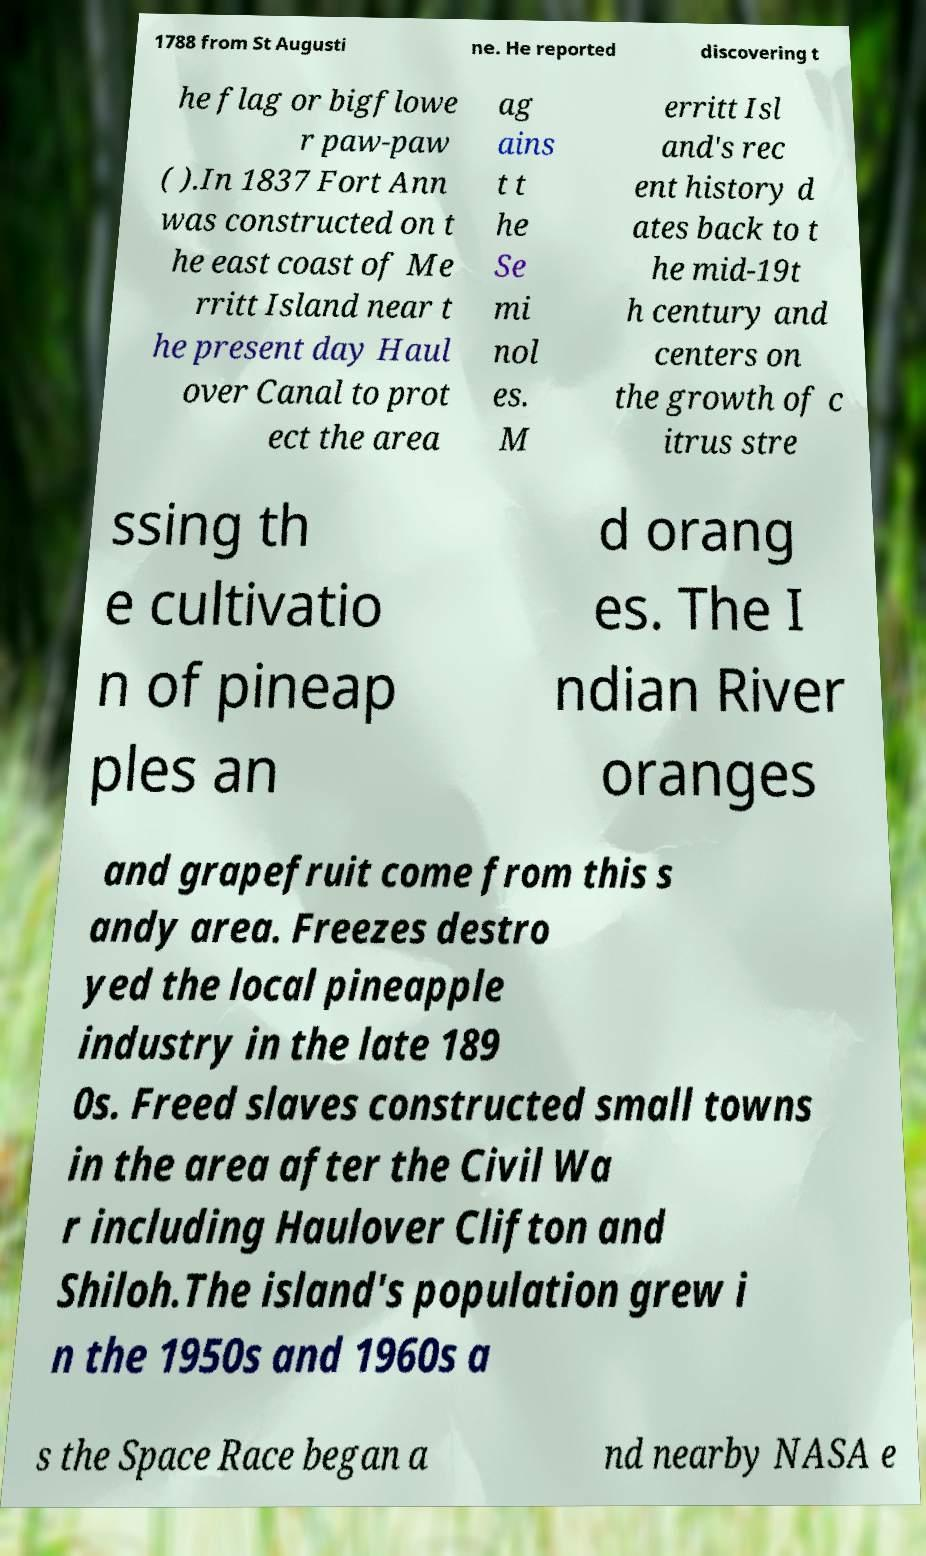What messages or text are displayed in this image? I need them in a readable, typed format. 1788 from St Augusti ne. He reported discovering t he flag or bigflowe r paw-paw ( ).In 1837 Fort Ann was constructed on t he east coast of Me rritt Island near t he present day Haul over Canal to prot ect the area ag ains t t he Se mi nol es. M erritt Isl and's rec ent history d ates back to t he mid-19t h century and centers on the growth of c itrus stre ssing th e cultivatio n of pineap ples an d orang es. The I ndian River oranges and grapefruit come from this s andy area. Freezes destro yed the local pineapple industry in the late 189 0s. Freed slaves constructed small towns in the area after the Civil Wa r including Haulover Clifton and Shiloh.The island's population grew i n the 1950s and 1960s a s the Space Race began a nd nearby NASA e 